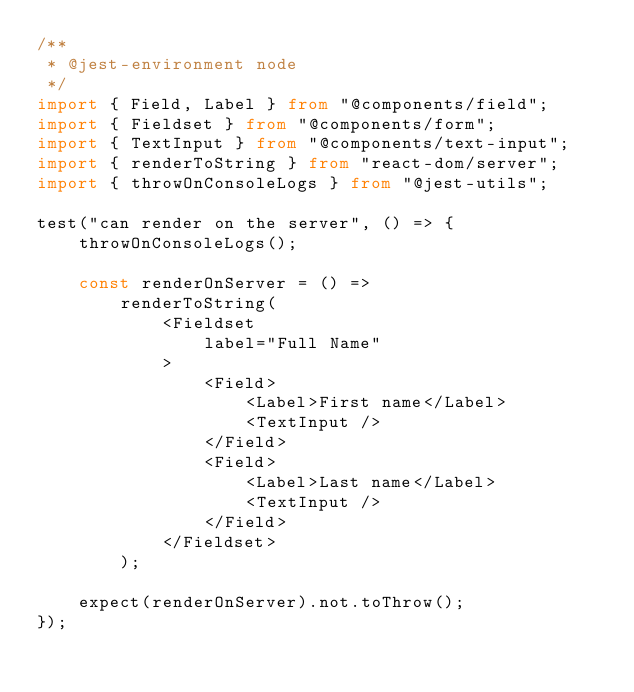<code> <loc_0><loc_0><loc_500><loc_500><_TypeScript_>/**
 * @jest-environment node
 */
import { Field, Label } from "@components/field";
import { Fieldset } from "@components/form";
import { TextInput } from "@components/text-input";
import { renderToString } from "react-dom/server";
import { throwOnConsoleLogs } from "@jest-utils";

test("can render on the server", () => {
    throwOnConsoleLogs();

    const renderOnServer = () =>
        renderToString(
            <Fieldset
                label="Full Name"
            >
                <Field>
                    <Label>First name</Label>
                    <TextInput />
                </Field>
                <Field>
                    <Label>Last name</Label>
                    <TextInput />
                </Field>
            </Fieldset>
        );

    expect(renderOnServer).not.toThrow();
});
</code> 